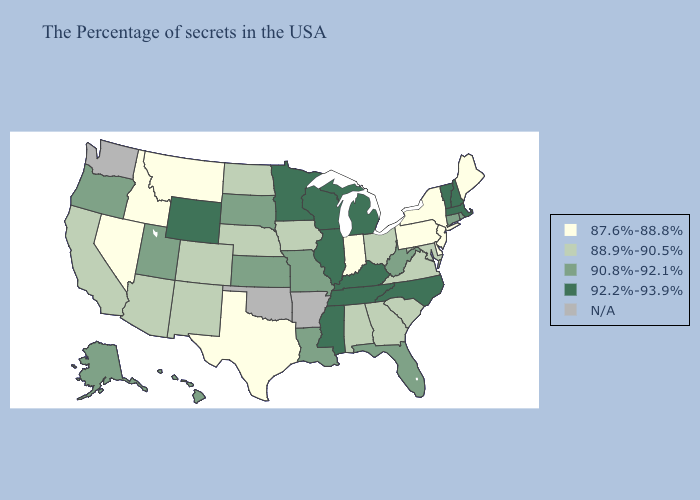What is the value of Massachusetts?
Give a very brief answer. 92.2%-93.9%. Name the states that have a value in the range 90.8%-92.1%?
Give a very brief answer. Rhode Island, Connecticut, West Virginia, Florida, Louisiana, Missouri, Kansas, South Dakota, Utah, Oregon, Alaska, Hawaii. Name the states that have a value in the range 90.8%-92.1%?
Short answer required. Rhode Island, Connecticut, West Virginia, Florida, Louisiana, Missouri, Kansas, South Dakota, Utah, Oregon, Alaska, Hawaii. Among the states that border Kansas , does Colorado have the highest value?
Quick response, please. No. What is the lowest value in the USA?
Answer briefly. 87.6%-88.8%. What is the value of California?
Keep it brief. 88.9%-90.5%. What is the value of Oregon?
Write a very short answer. 90.8%-92.1%. Does Mississippi have the highest value in the South?
Give a very brief answer. Yes. Name the states that have a value in the range 88.9%-90.5%?
Give a very brief answer. Maryland, Virginia, South Carolina, Ohio, Georgia, Alabama, Iowa, Nebraska, North Dakota, Colorado, New Mexico, Arizona, California. Name the states that have a value in the range 88.9%-90.5%?
Quick response, please. Maryland, Virginia, South Carolina, Ohio, Georgia, Alabama, Iowa, Nebraska, North Dakota, Colorado, New Mexico, Arizona, California. Name the states that have a value in the range N/A?
Keep it brief. Arkansas, Oklahoma, Washington. Does the first symbol in the legend represent the smallest category?
Answer briefly. Yes. Which states have the lowest value in the South?
Keep it brief. Delaware, Texas. Among the states that border California , does Oregon have the lowest value?
Concise answer only. No. 